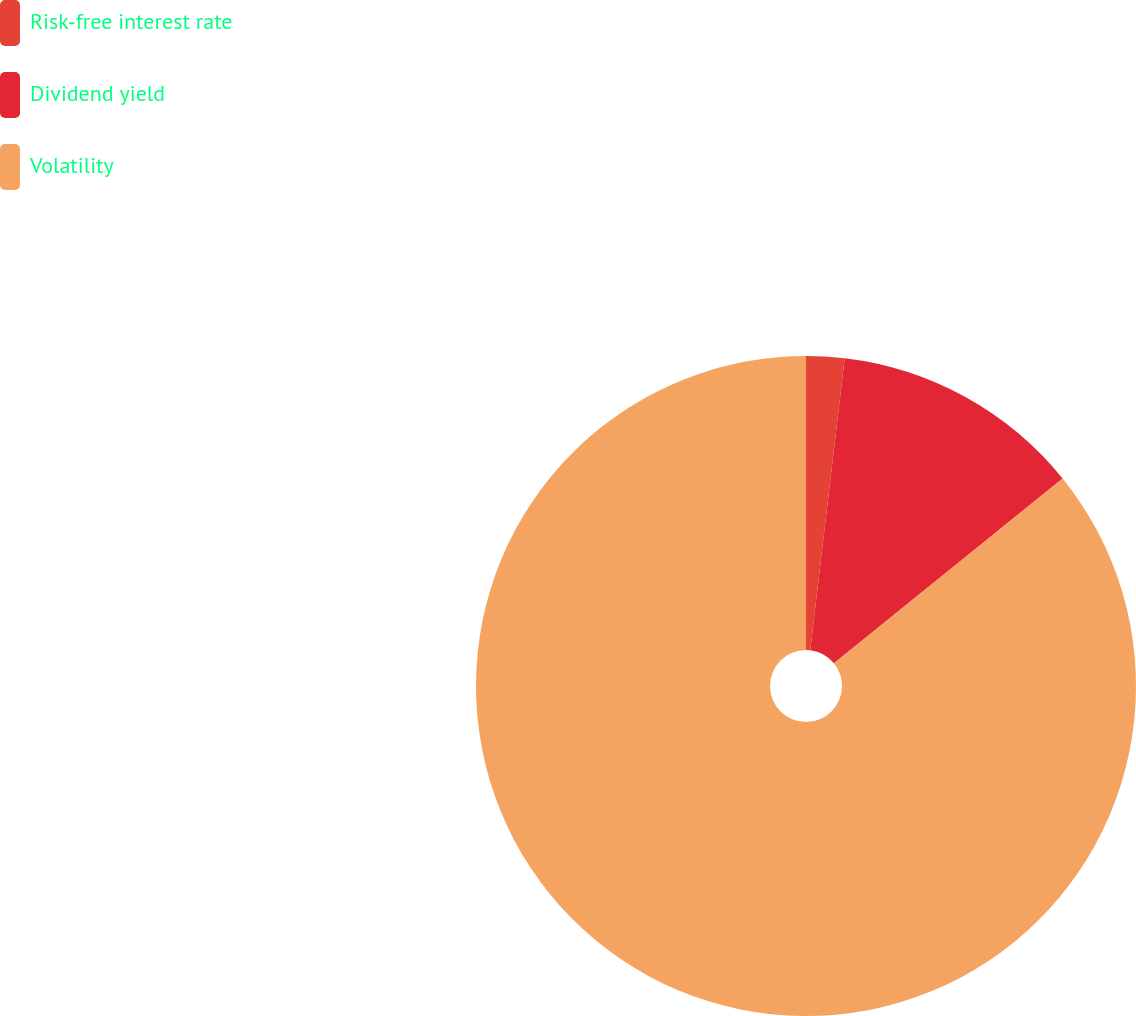<chart> <loc_0><loc_0><loc_500><loc_500><pie_chart><fcel>Risk-free interest rate<fcel>Dividend yield<fcel>Volatility<nl><fcel>1.87%<fcel>12.31%<fcel>85.82%<nl></chart> 